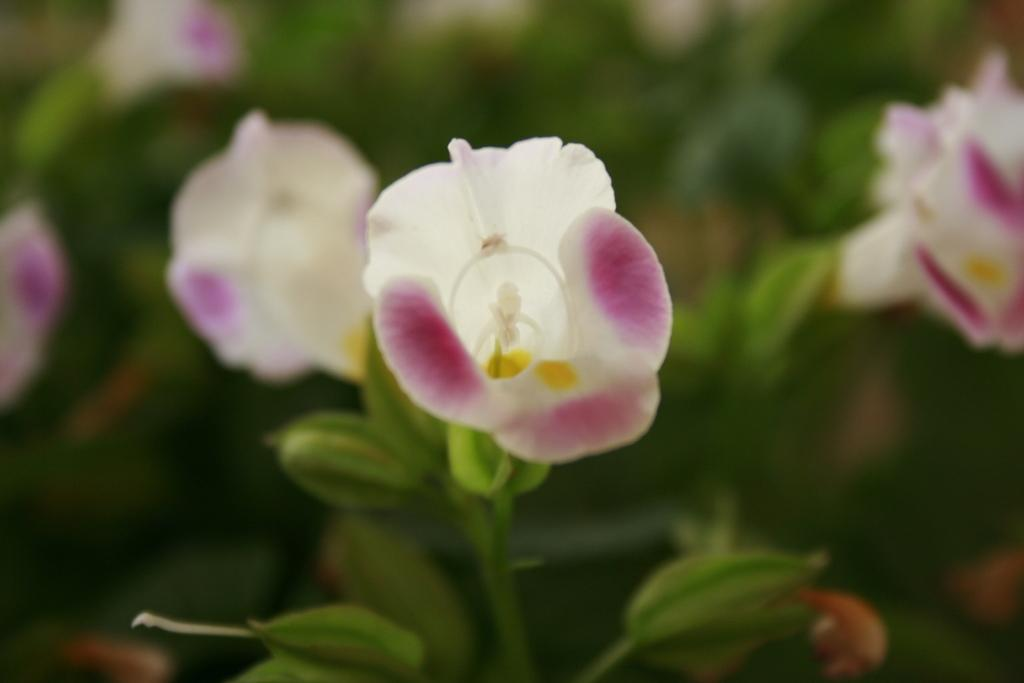What type of plant is visible in the image? The image contains a flower on a plant. Can you describe the background of the image? The background of the image is blurred. What type of milk is being poured into the flower in the image? There is no milk being poured into the flower in the image; it only contains a flower on a plant. 